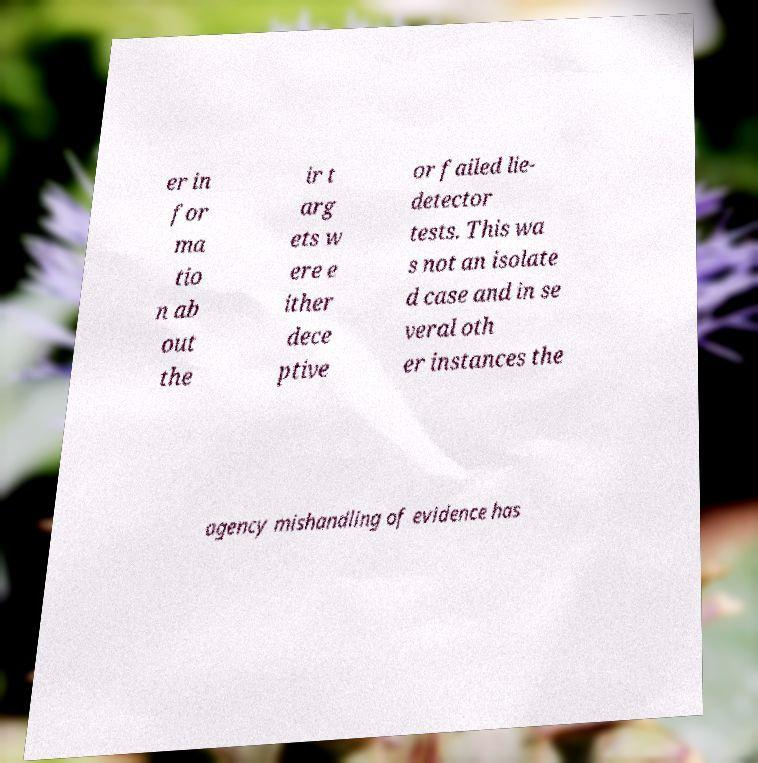What messages or text are displayed in this image? I need them in a readable, typed format. er in for ma tio n ab out the ir t arg ets w ere e ither dece ptive or failed lie- detector tests. This wa s not an isolate d case and in se veral oth er instances the agency mishandling of evidence has 